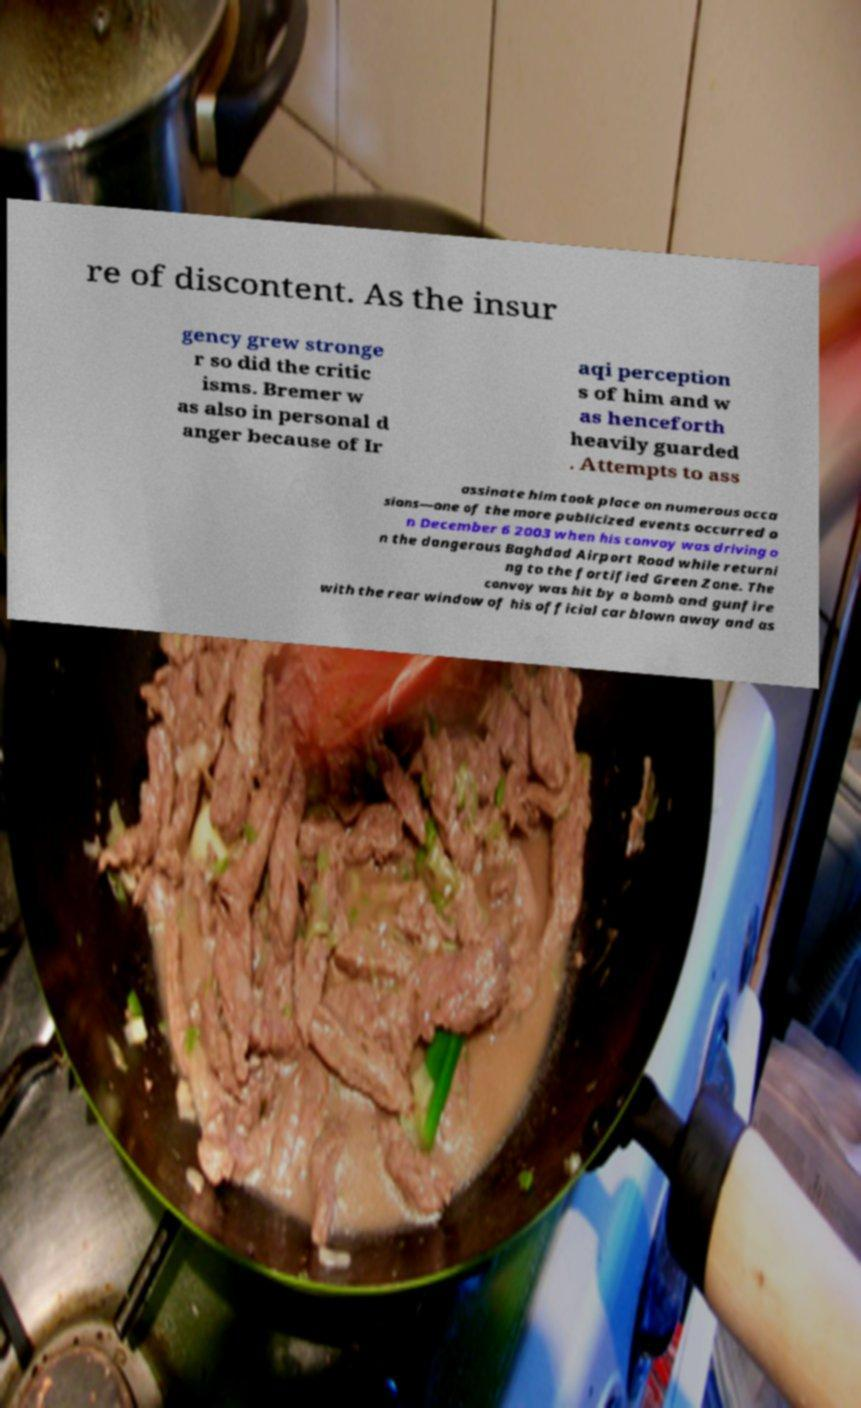Could you assist in decoding the text presented in this image and type it out clearly? re of discontent. As the insur gency grew stronge r so did the critic isms. Bremer w as also in personal d anger because of Ir aqi perception s of him and w as henceforth heavily guarded . Attempts to ass assinate him took place on numerous occa sions—one of the more publicized events occurred o n December 6 2003 when his convoy was driving o n the dangerous Baghdad Airport Road while returni ng to the fortified Green Zone. The convoy was hit by a bomb and gunfire with the rear window of his official car blown away and as 